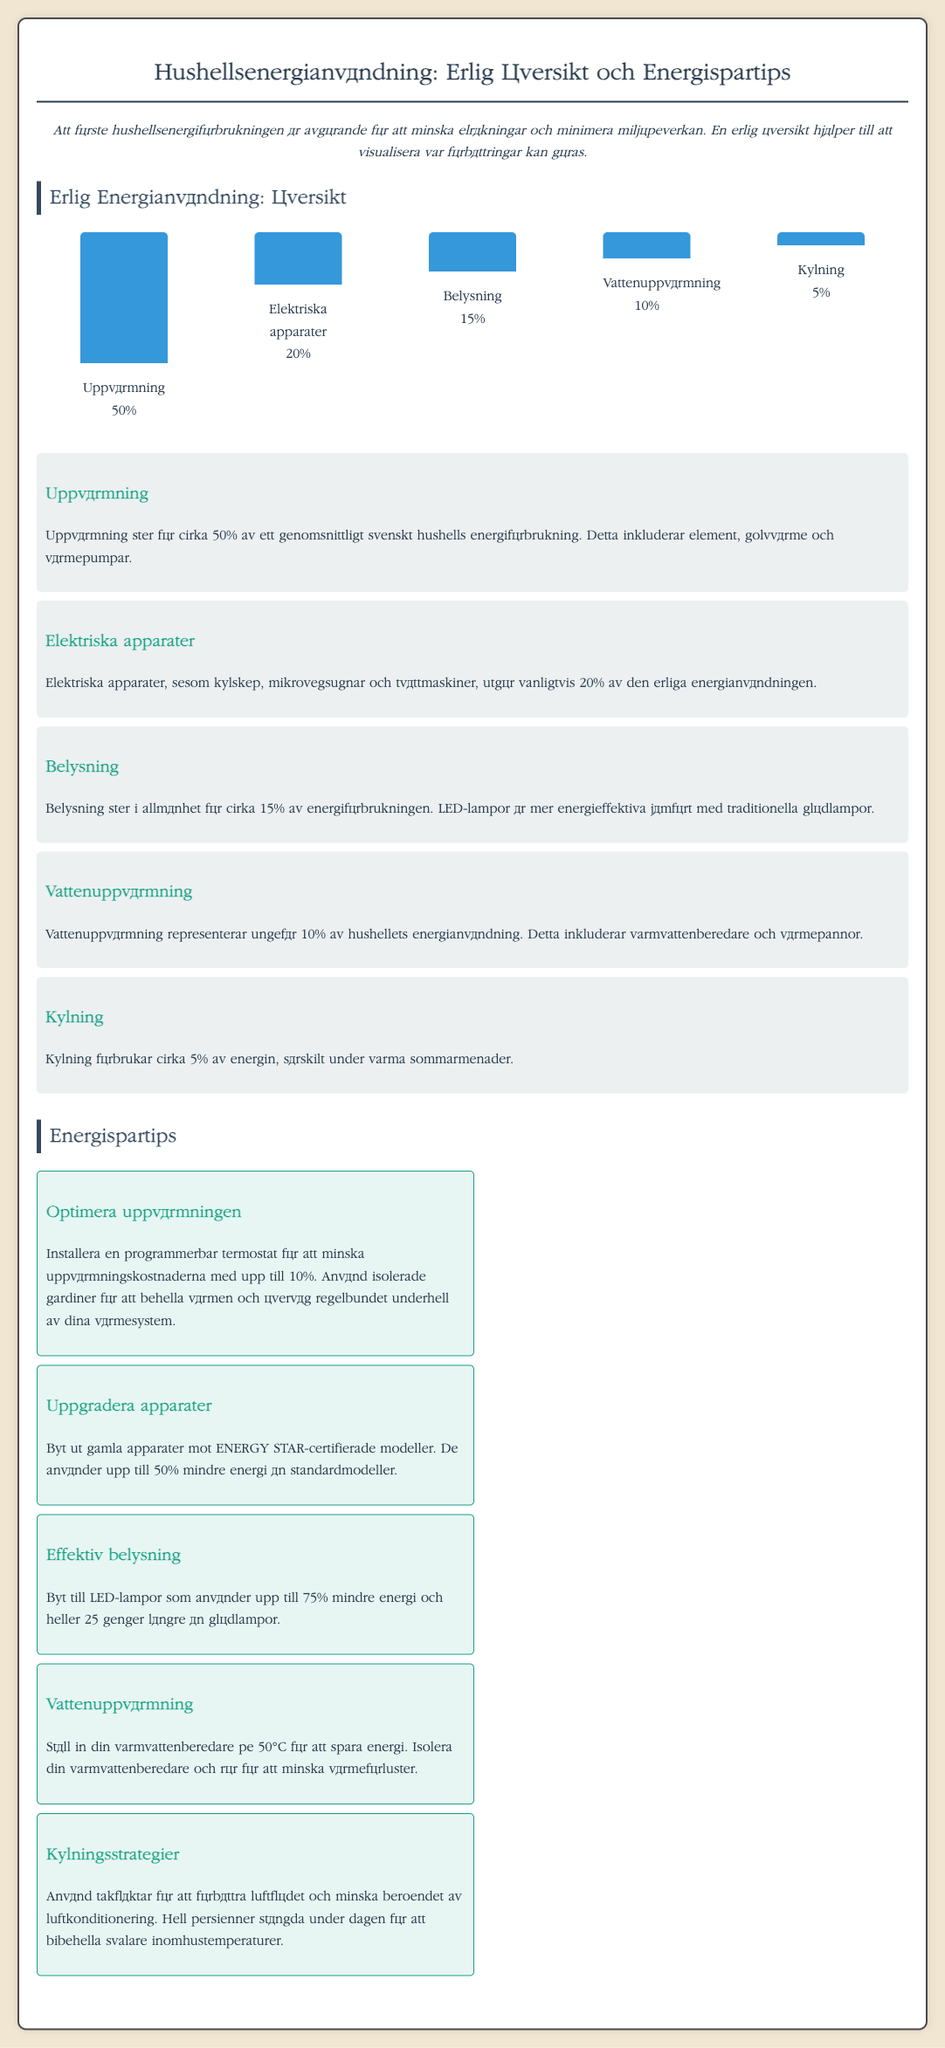what percentage of annual energy consumption is used for heating? The document indicates that heating accounts for approximately 50% of annual energy consumption in a typical Swedish household.
Answer: 50% what energy-saving tip can reduce heating costs by up to 10%? The tip suggests installing a programmable thermostat to lower heating costs.
Answer: Programmable thermostat how much energy do LED bulbs use compared to traditional bulbs? The infographic states that LED bulbs use up to 75% less energy than traditional incandescent bulbs.
Answer: 75% what is the percentage of energy consumption attributed to water heating in households? The document mentions that water heating represents around 10% of household energy consumption.
Answer: 10% which appliances contribute to 20% of energy consumption? The document specifies that electrical appliances such as refrigerators and microwaves contribute to 20% of total energy consumption.
Answer: Electrical appliances what is recommended for saving energy on water heating? Insulating the water heater and pipes is recommended to minimize heat loss and conserve energy.
Answer: Insulate water heater how many times longer do LED bulbs last compared to Incandescent bulbs? The document states that LED bulbs last 25 times longer than incandescent bulbs.
Answer: 25 times what is the percentage of energy used for cooling? The infographic indicates that cooling accounts for about 5% of energy consumption in households.
Answer: 5% 